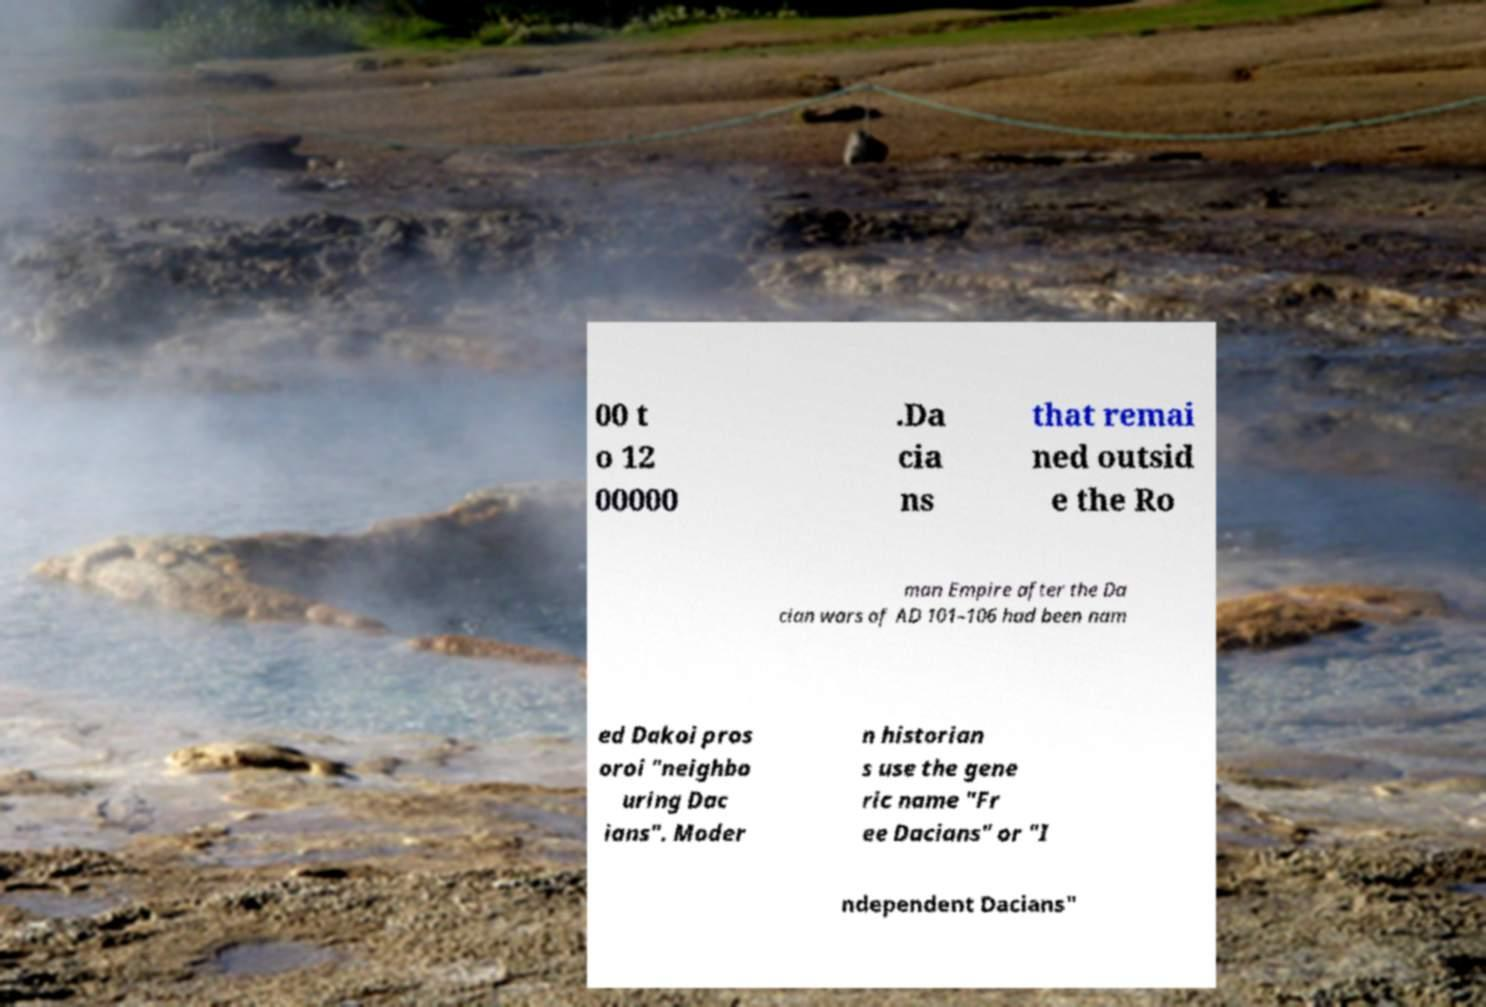I need the written content from this picture converted into text. Can you do that? 00 t o 12 00000 .Da cia ns that remai ned outsid e the Ro man Empire after the Da cian wars of AD 101–106 had been nam ed Dakoi pros oroi "neighbo uring Dac ians". Moder n historian s use the gene ric name "Fr ee Dacians" or "I ndependent Dacians" 